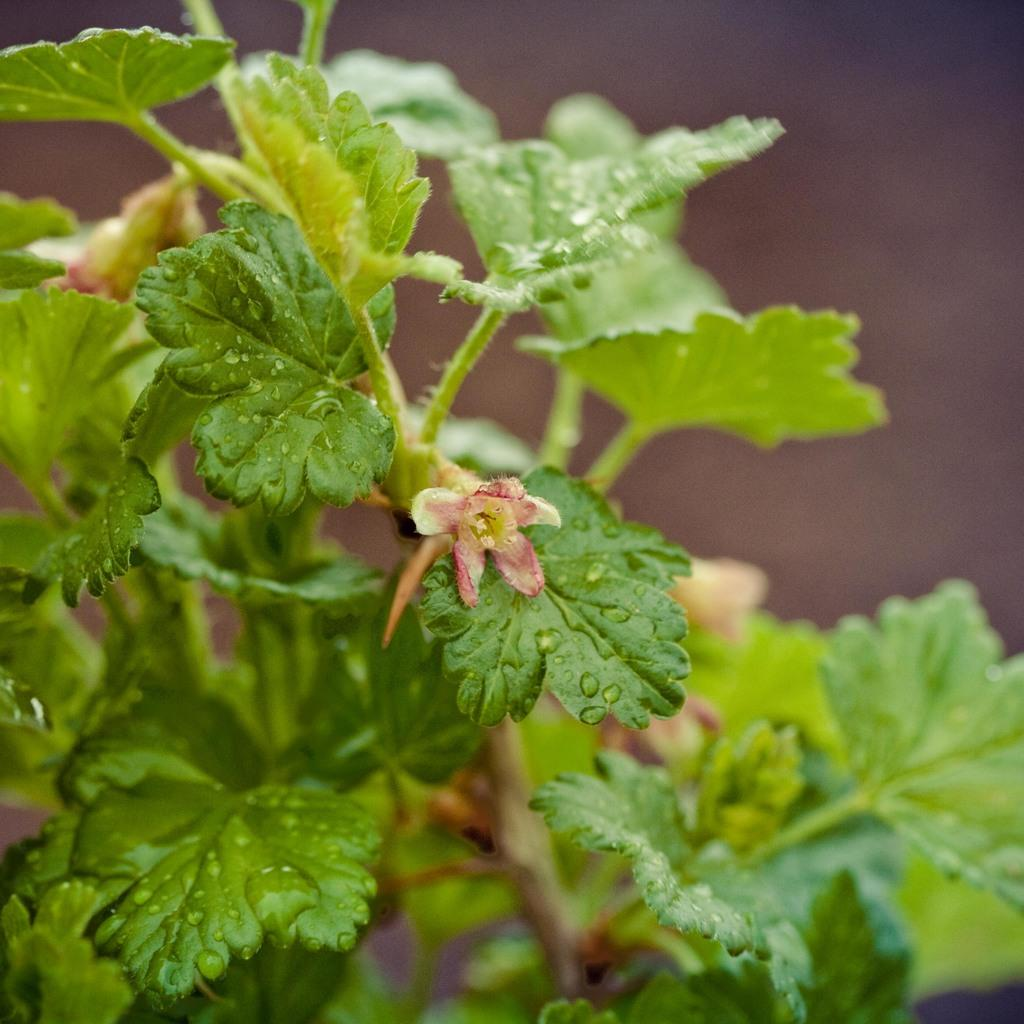What type of plant can be seen in the image? There is a plant with flowers in the image. Can you describe the background of the image? The background of the image is blurred. Reasoning: Let'g: Let's think step by step in order to produce the conversation. We start by identifying the main subject in the image, which is the plant with flowers. Then, we expand the conversation to include the background of the image, which is described as blurred. Each question is designed to elicit a specific detail about the image that is known from the provided facts. Absurd Question/Answer: How does the plant push the knowledge in the image? There is no mention of knowledge or pushing in the image; it only features a plant with flowers and a blurred background. 